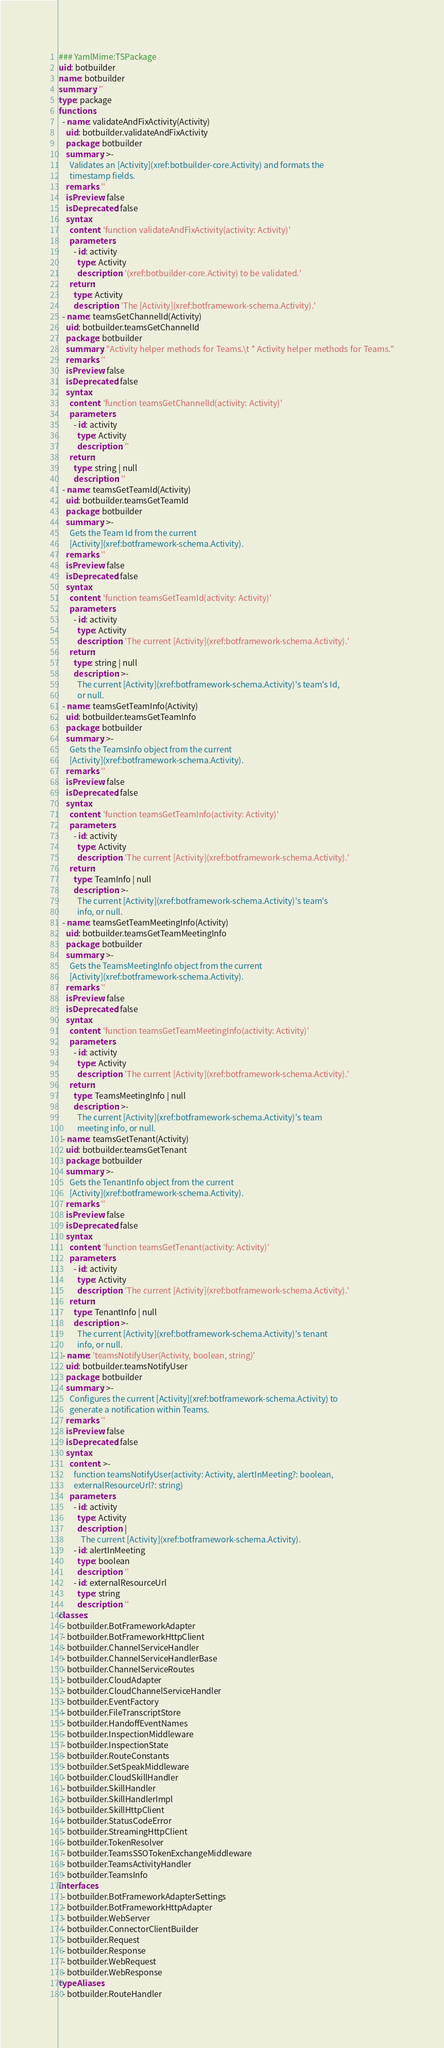Convert code to text. <code><loc_0><loc_0><loc_500><loc_500><_YAML_>### YamlMime:TSPackage
uid: botbuilder
name: botbuilder
summary: ''
type: package
functions:
  - name: validateAndFixActivity(Activity)
    uid: botbuilder.validateAndFixActivity
    package: botbuilder
    summary: >-
      Validates an [Activity](xref:botbuilder-core.Activity) and formats the
      timestamp fields.
    remarks: ''
    isPreview: false
    isDeprecated: false
    syntax:
      content: 'function validateAndFixActivity(activity: Activity)'
      parameters:
        - id: activity
          type: Activity
          description: '(xref:botbuilder-core.Activity) to be validated.'
      return:
        type: Activity
        description: 'The [Activity](xref:botframework-schema.Activity).'
  - name: teamsGetChannelId(Activity)
    uid: botbuilder.teamsGetChannelId
    package: botbuilder
    summary: "Activity helper methods for Teams.\t * Activity helper methods for Teams."
    remarks: ''
    isPreview: false
    isDeprecated: false
    syntax:
      content: 'function teamsGetChannelId(activity: Activity)'
      parameters:
        - id: activity
          type: Activity
          description: ''
      return:
        type: string | null
        description: ''
  - name: teamsGetTeamId(Activity)
    uid: botbuilder.teamsGetTeamId
    package: botbuilder
    summary: >-
      Gets the Team Id from the current
      [Activity](xref:botframework-schema.Activity).
    remarks: ''
    isPreview: false
    isDeprecated: false
    syntax:
      content: 'function teamsGetTeamId(activity: Activity)'
      parameters:
        - id: activity
          type: Activity
          description: 'The current [Activity](xref:botframework-schema.Activity).'
      return:
        type: string | null
        description: >-
          The current [Activity](xref:botframework-schema.Activity)'s team's Id,
          or null.
  - name: teamsGetTeamInfo(Activity)
    uid: botbuilder.teamsGetTeamInfo
    package: botbuilder
    summary: >-
      Gets the TeamsInfo object from the current
      [Activity](xref:botframework-schema.Activity).
    remarks: ''
    isPreview: false
    isDeprecated: false
    syntax:
      content: 'function teamsGetTeamInfo(activity: Activity)'
      parameters:
        - id: activity
          type: Activity
          description: 'The current [Activity](xref:botframework-schema.Activity).'
      return:
        type: TeamInfo | null
        description: >-
          The current [Activity](xref:botframework-schema.Activity)'s team's
          info, or null.
  - name: teamsGetTeamMeetingInfo(Activity)
    uid: botbuilder.teamsGetTeamMeetingInfo
    package: botbuilder
    summary: >-
      Gets the TeamsMeetingInfo object from the current
      [Activity](xref:botframework-schema.Activity).
    remarks: ''
    isPreview: false
    isDeprecated: false
    syntax:
      content: 'function teamsGetTeamMeetingInfo(activity: Activity)'
      parameters:
        - id: activity
          type: Activity
          description: 'The current [Activity](xref:botframework-schema.Activity).'
      return:
        type: TeamsMeetingInfo | null
        description: >-
          The current [Activity](xref:botframework-schema.Activity)'s team
          meeting info, or null.
  - name: teamsGetTenant(Activity)
    uid: botbuilder.teamsGetTenant
    package: botbuilder
    summary: >-
      Gets the TenantInfo object from the current
      [Activity](xref:botframework-schema.Activity).
    remarks: ''
    isPreview: false
    isDeprecated: false
    syntax:
      content: 'function teamsGetTenant(activity: Activity)'
      parameters:
        - id: activity
          type: Activity
          description: 'The current [Activity](xref:botframework-schema.Activity).'
      return:
        type: TenantInfo | null
        description: >-
          The current [Activity](xref:botframework-schema.Activity)'s tenant
          info, or null.
  - name: 'teamsNotifyUser(Activity, boolean, string)'
    uid: botbuilder.teamsNotifyUser
    package: botbuilder
    summary: >-
      Configures the current [Activity](xref:botframework-schema.Activity) to
      generate a notification within Teams.
    remarks: ''
    isPreview: false
    isDeprecated: false
    syntax:
      content: >-
        function teamsNotifyUser(activity: Activity, alertInMeeting?: boolean,
        externalResourceUrl?: string)
      parameters:
        - id: activity
          type: Activity
          description: |
            The current [Activity](xref:botframework-schema.Activity).
        - id: alertInMeeting
          type: boolean
          description: ''
        - id: externalResourceUrl
          type: string
          description: ''
classes:
  - botbuilder.BotFrameworkAdapter
  - botbuilder.BotFrameworkHttpClient
  - botbuilder.ChannelServiceHandler
  - botbuilder.ChannelServiceHandlerBase
  - botbuilder.ChannelServiceRoutes
  - botbuilder.CloudAdapter
  - botbuilder.CloudChannelServiceHandler
  - botbuilder.EventFactory
  - botbuilder.FileTranscriptStore
  - botbuilder.HandoffEventNames
  - botbuilder.InspectionMiddleware
  - botbuilder.InspectionState
  - botbuilder.RouteConstants
  - botbuilder.SetSpeakMiddleware
  - botbuilder.CloudSkillHandler
  - botbuilder.SkillHandler
  - botbuilder.SkillHandlerImpl
  - botbuilder.SkillHttpClient
  - botbuilder.StatusCodeError
  - botbuilder.StreamingHttpClient
  - botbuilder.TokenResolver
  - botbuilder.TeamsSSOTokenExchangeMiddleware
  - botbuilder.TeamsActivityHandler
  - botbuilder.TeamsInfo
interfaces:
  - botbuilder.BotFrameworkAdapterSettings
  - botbuilder.BotFrameworkHttpAdapter
  - botbuilder.WebServer
  - botbuilder.ConnectorClientBuilder
  - botbuilder.Request
  - botbuilder.Response
  - botbuilder.WebRequest
  - botbuilder.WebResponse
typeAliases:
  - botbuilder.RouteHandler
</code> 